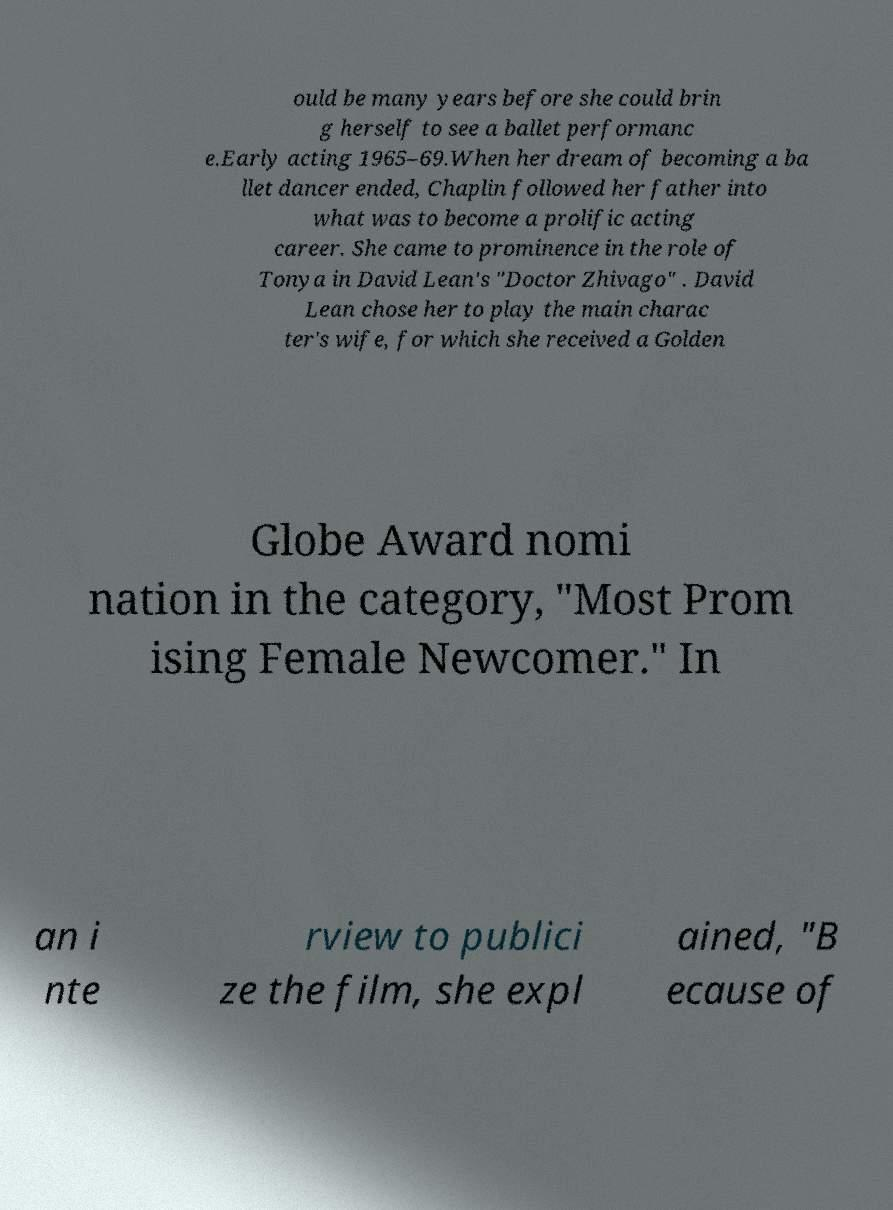Can you accurately transcribe the text from the provided image for me? ould be many years before she could brin g herself to see a ballet performanc e.Early acting 1965–69.When her dream of becoming a ba llet dancer ended, Chaplin followed her father into what was to become a prolific acting career. She came to prominence in the role of Tonya in David Lean's "Doctor Zhivago" . David Lean chose her to play the main charac ter's wife, for which she received a Golden Globe Award nomi nation in the category, "Most Prom ising Female Newcomer." In an i nte rview to publici ze the film, she expl ained, "B ecause of 